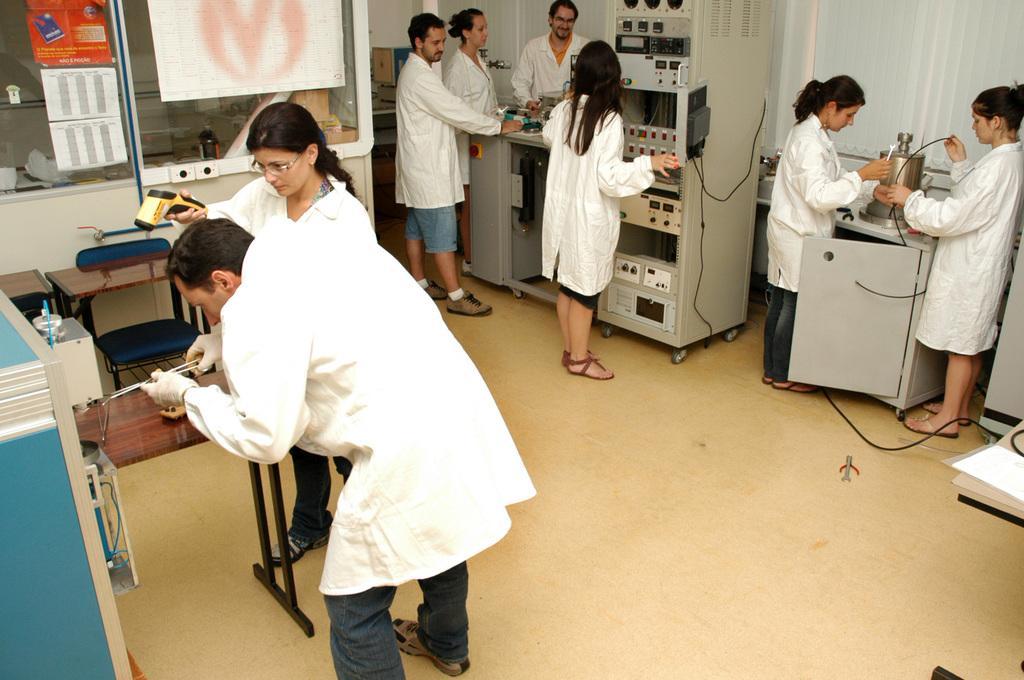How would you summarize this image in a sentence or two? In this image there are group of people who are standing on the right side there are two women who are standing and one woman is holding a wire on the right side. And in the middle of the image there are four persons who are standing and in front of them there is one machine, and on the left side there are two persons who are standing and one person is holding something. And beside this person another woman who is standing is holding something, beside them there are two tables and one chair and on the top of the right corner there is one curtain and on the left corner there is one glass window and on the glass window there are some posters. 